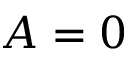Convert formula to latex. <formula><loc_0><loc_0><loc_500><loc_500>A = 0</formula> 